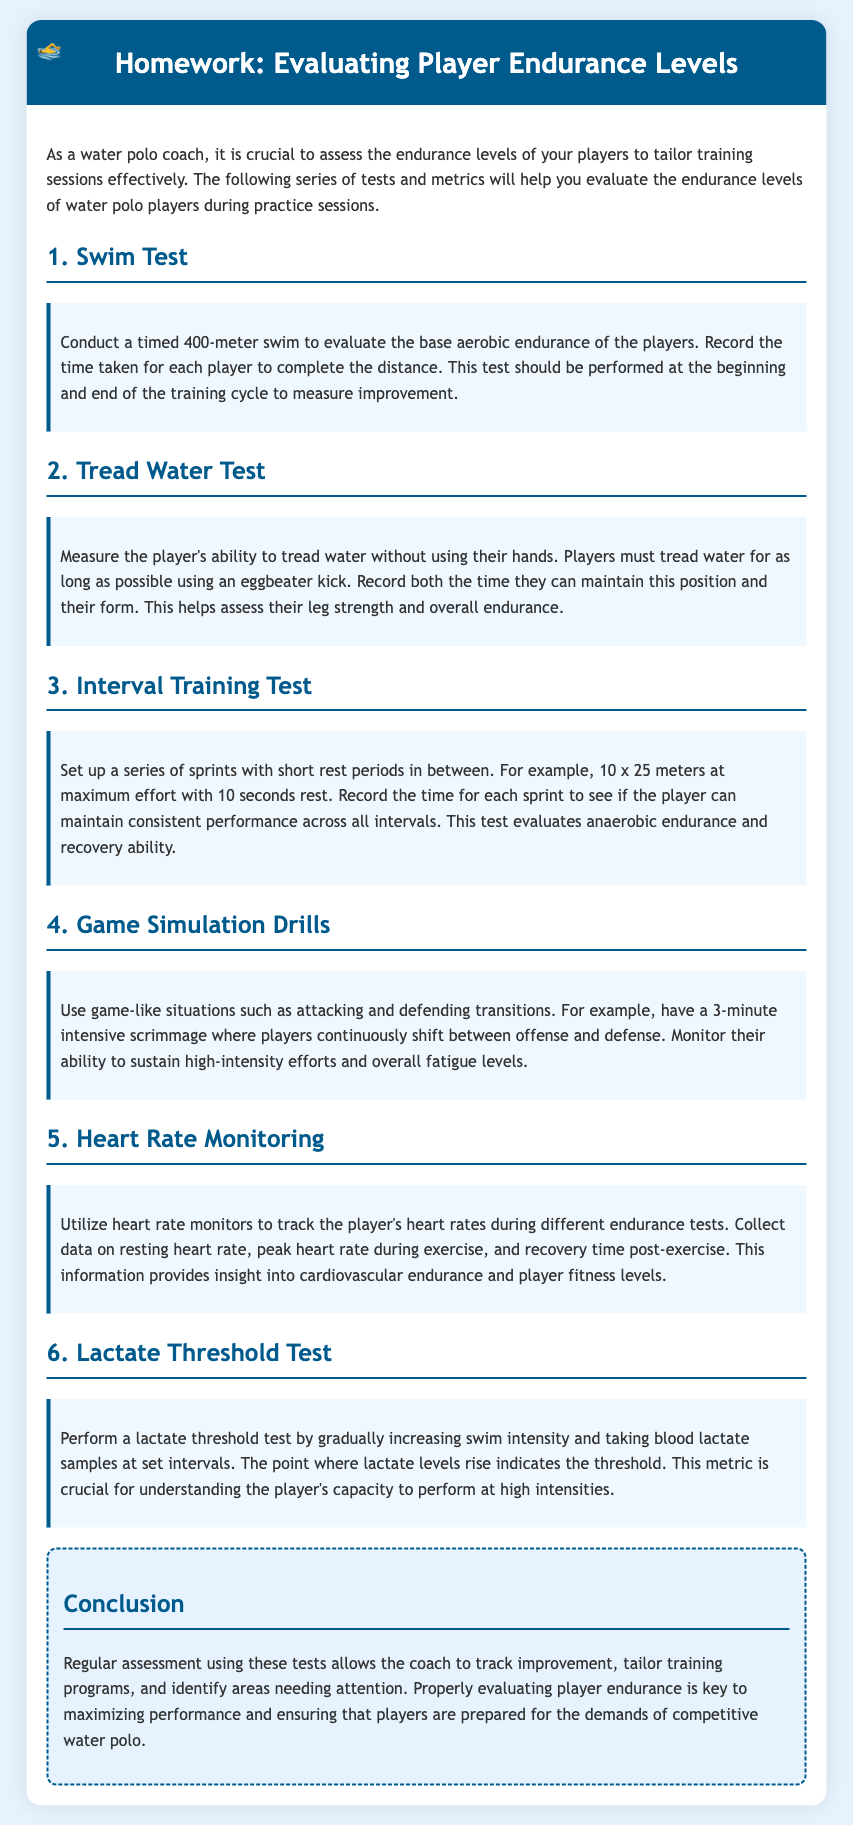what is the first test mentioned in the document? The first test mentioned is the Swim Test, which evaluates the base aerobic endurance of players.
Answer: Swim Test what distance is used for the timed swim test? The document specifies a timed distance of 400 meters for the swim test.
Answer: 400 meters how long should players tread water in the Tread Water Test? Players must tread water for as long as possible using an eggbeater kick.
Answer: As long as possible what is measured during the Interval Training Test? The time for each sprint is recorded to see if the player can maintain consistent performance.
Answer: The time for each sprint what technology is suggested for monitoring player endurance levels? Heart rate monitors are suggested to track the player's heart rates during tests.
Answer: Heart rate monitors how is the Lactate Threshold Test performed? The test is performed by gradually increasing swim intensity and taking blood lactate samples at set intervals.
Answer: Gradually increasing swim intensity what is the purpose of regular assessments using these tests? Regular assessments allow the coach to track improvement and tailor training programs.
Answer: Track improvement what should the heart rate be monitored for during the endurance tests? It should be monitored for resting heart rate, peak heart rate during exercise, and recovery time post-exercise.
Answer: Resting heart rate, peak heart rate, recovery time what does the Game Simulation Drills test evaluate? This test evaluates the player's ability to sustain high-intensity efforts and overall fatigue levels.
Answer: High-intensity efforts and fatigue levels 